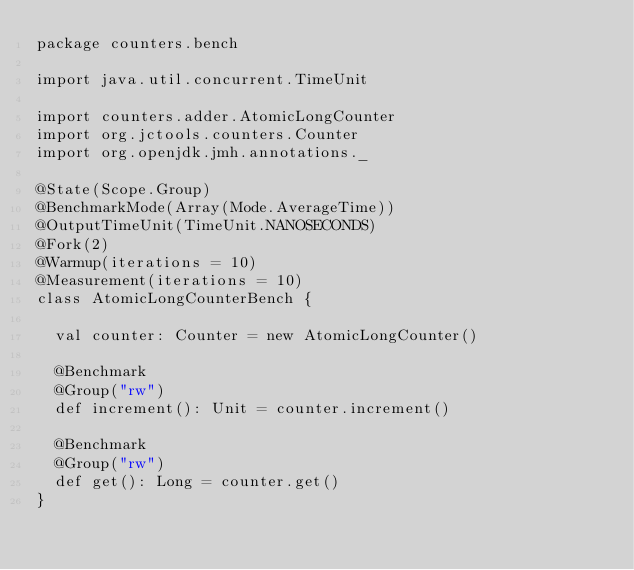<code> <loc_0><loc_0><loc_500><loc_500><_Scala_>package counters.bench

import java.util.concurrent.TimeUnit

import counters.adder.AtomicLongCounter
import org.jctools.counters.Counter
import org.openjdk.jmh.annotations._

@State(Scope.Group)
@BenchmarkMode(Array(Mode.AverageTime))
@OutputTimeUnit(TimeUnit.NANOSECONDS)
@Fork(2)
@Warmup(iterations = 10)
@Measurement(iterations = 10)
class AtomicLongCounterBench {

  val counter: Counter = new AtomicLongCounter()

  @Benchmark
  @Group("rw")
  def increment(): Unit = counter.increment()

  @Benchmark
  @Group("rw")
  def get(): Long = counter.get()
}</code> 